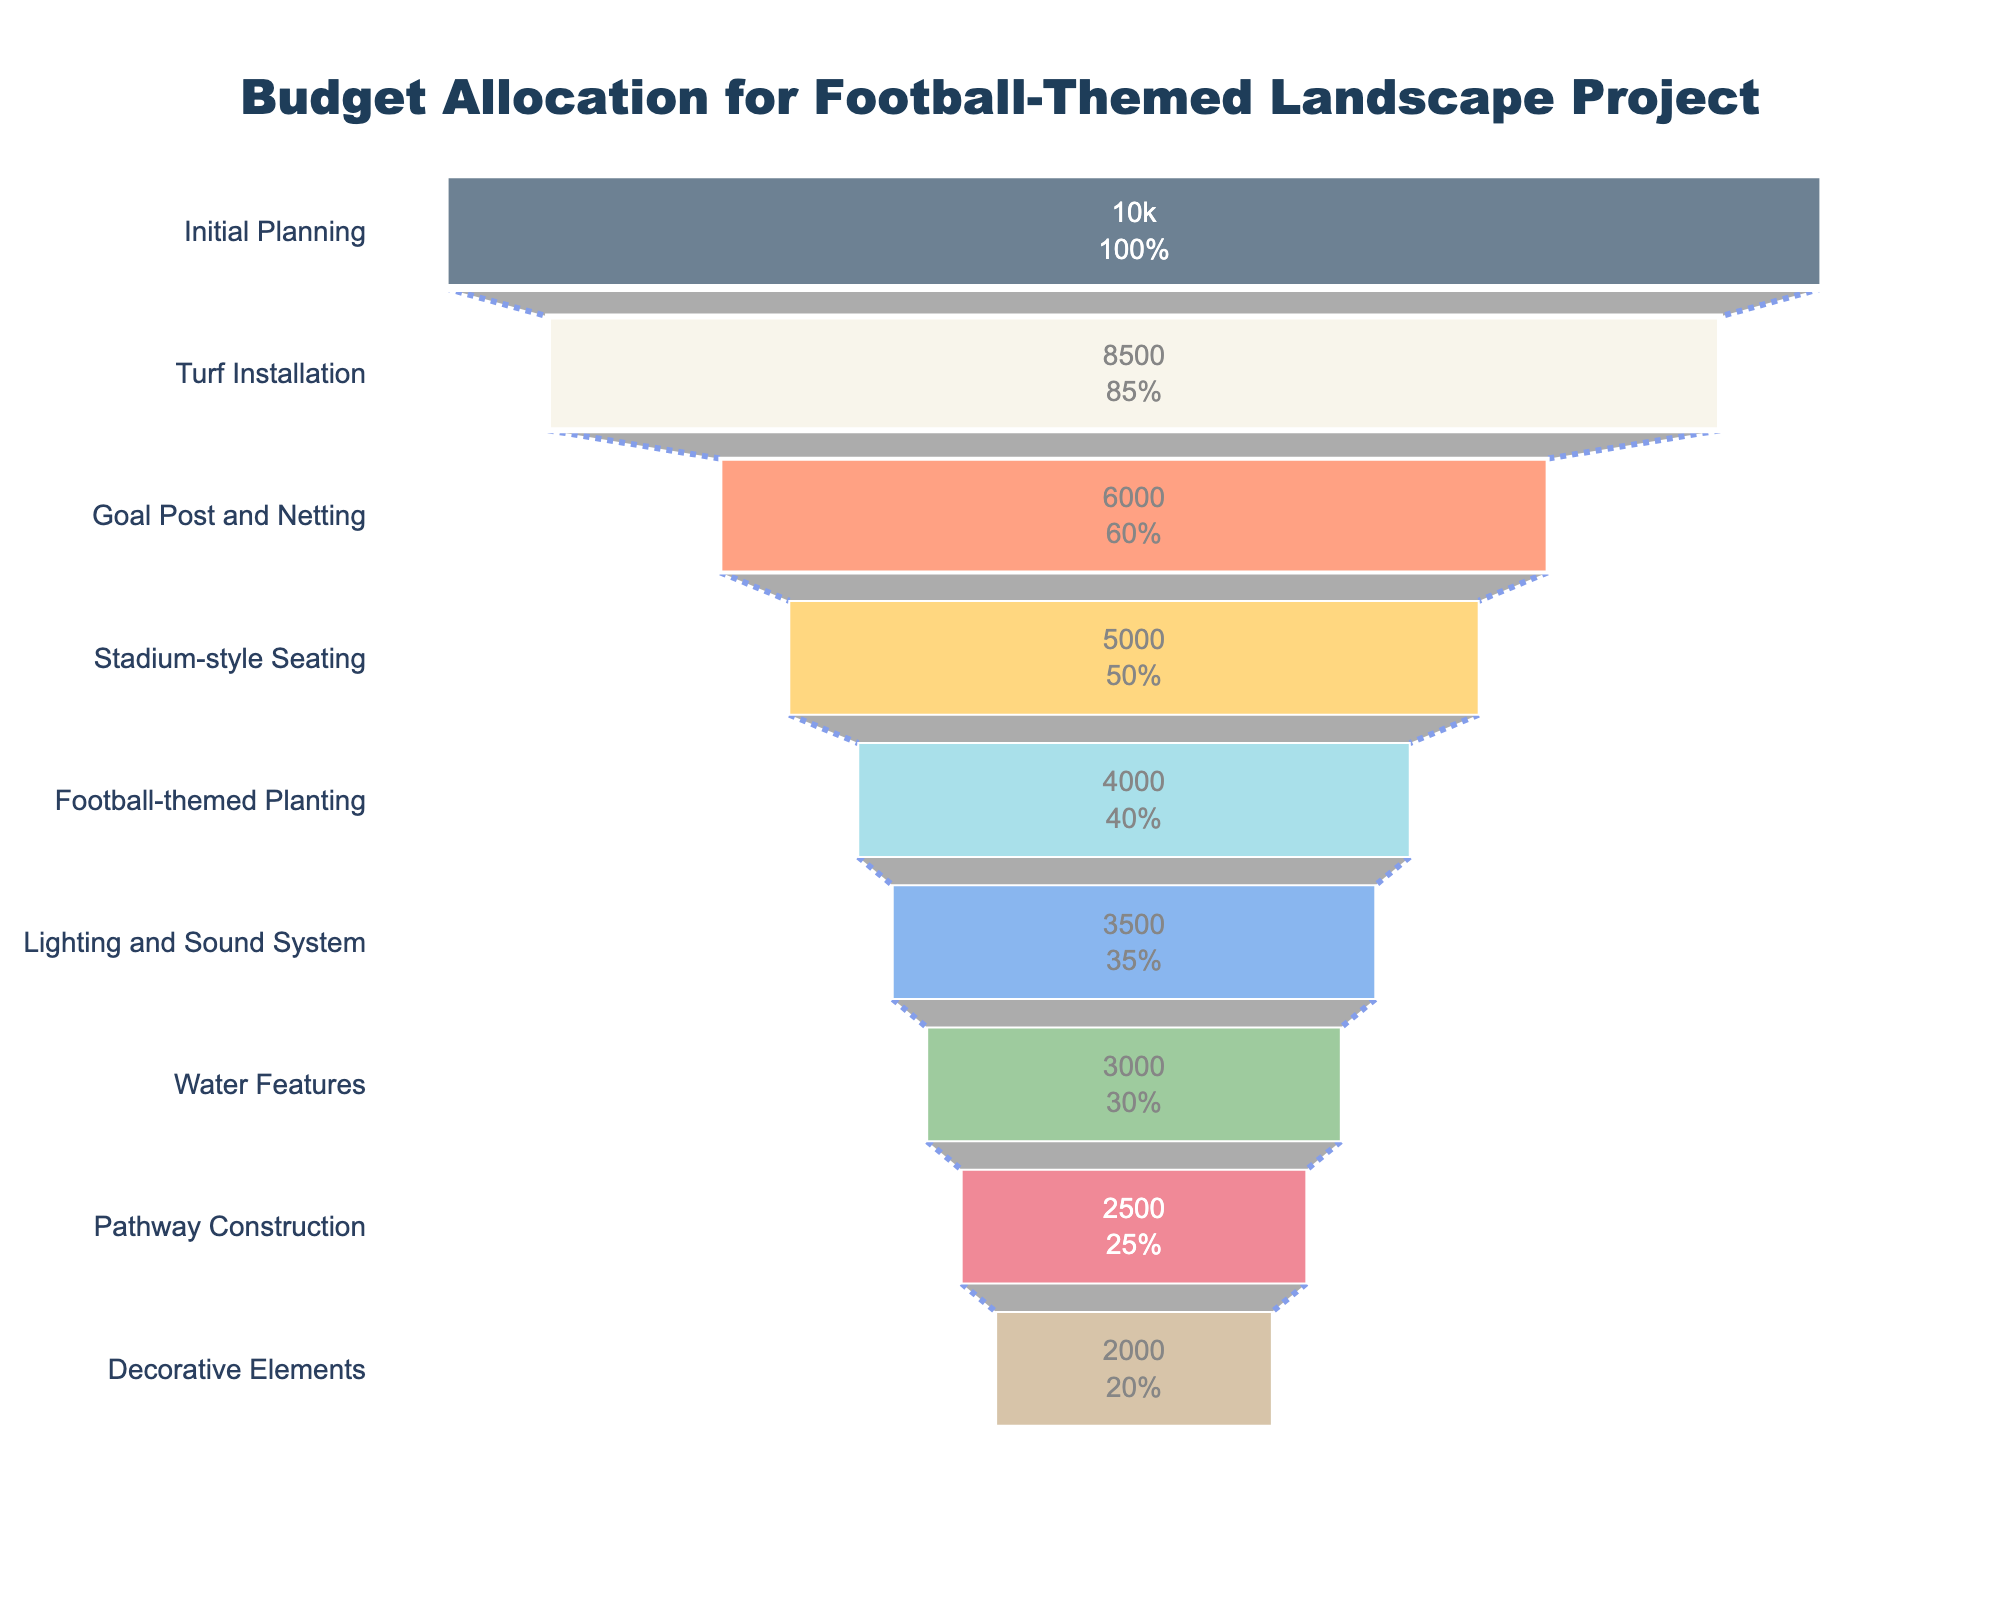What is the total budget allocation for the project? Sum up all the budget allocation values: 10000 + 8500 + 6000 + 5000 + 4000 + 3500 + 3000 + 2500 + 2000 = 49500
Answer: 49500 Which stage has the highest budget allocation? Look for the stage with the longest bar, which represents the highest value. "Initial Planning" has the longest bar with a budget allocation of $10000
Answer: Initial Planning How much more is allocated to Turf Installation compared to Water Features? Subtract the budget for Water Features from that of Turf Installation: 8500 - 3000 = 5500
Answer: 5500 What percentage of the initial budget is allocated to Stadium-style Seating? Divide the budget for Stadium-style Seating by the initial budget and multiply by 100: (5000 / 10000) * 100 = 50%
Answer: 50% Which stage has the smallest budget allocation? Find the bar with the shortest length. "Decorative Elements" has the shortest bar with a budget allocation of $2000
Answer: Decorative Elements Is the budget for Lighting and Sound System greater than or less than the budget for Goal Post and Netting? Compare the values: Lighting and Sound System ($3500) is less than Goal Post and Netting ($6000)
Answer: Less than How much is the combined budget for the Goal Post and Netting and Stadium-style Seating stages? Add the budgets for both stages: 6000 + 5000 = 11000
Answer: 11000 What is the average budget allocation across all stages? Calculate the average by dividing the total budget by the number of stages: 49500 / 9 = 5500
Answer: 5500 What is the difference in budget allocation between Initial Planning and Pathway Construction? Subtract the budget for Pathway Construction from that of Initial Planning: 10000 - 2500 = 7500
Answer: 7500 